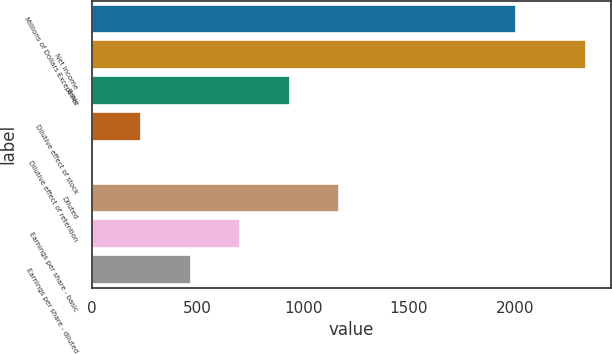Convert chart. <chart><loc_0><loc_0><loc_500><loc_500><bar_chart><fcel>Millions of Dollars Except Per<fcel>Net income<fcel>Basic<fcel>Dilutive effect of stock<fcel>Dilutive effect of retention<fcel>Diluted<fcel>Earnings per share - basic<fcel>Earnings per share - diluted<nl><fcel>2008<fcel>2338<fcel>935.8<fcel>234.7<fcel>1<fcel>1169.5<fcel>702.1<fcel>468.4<nl></chart> 